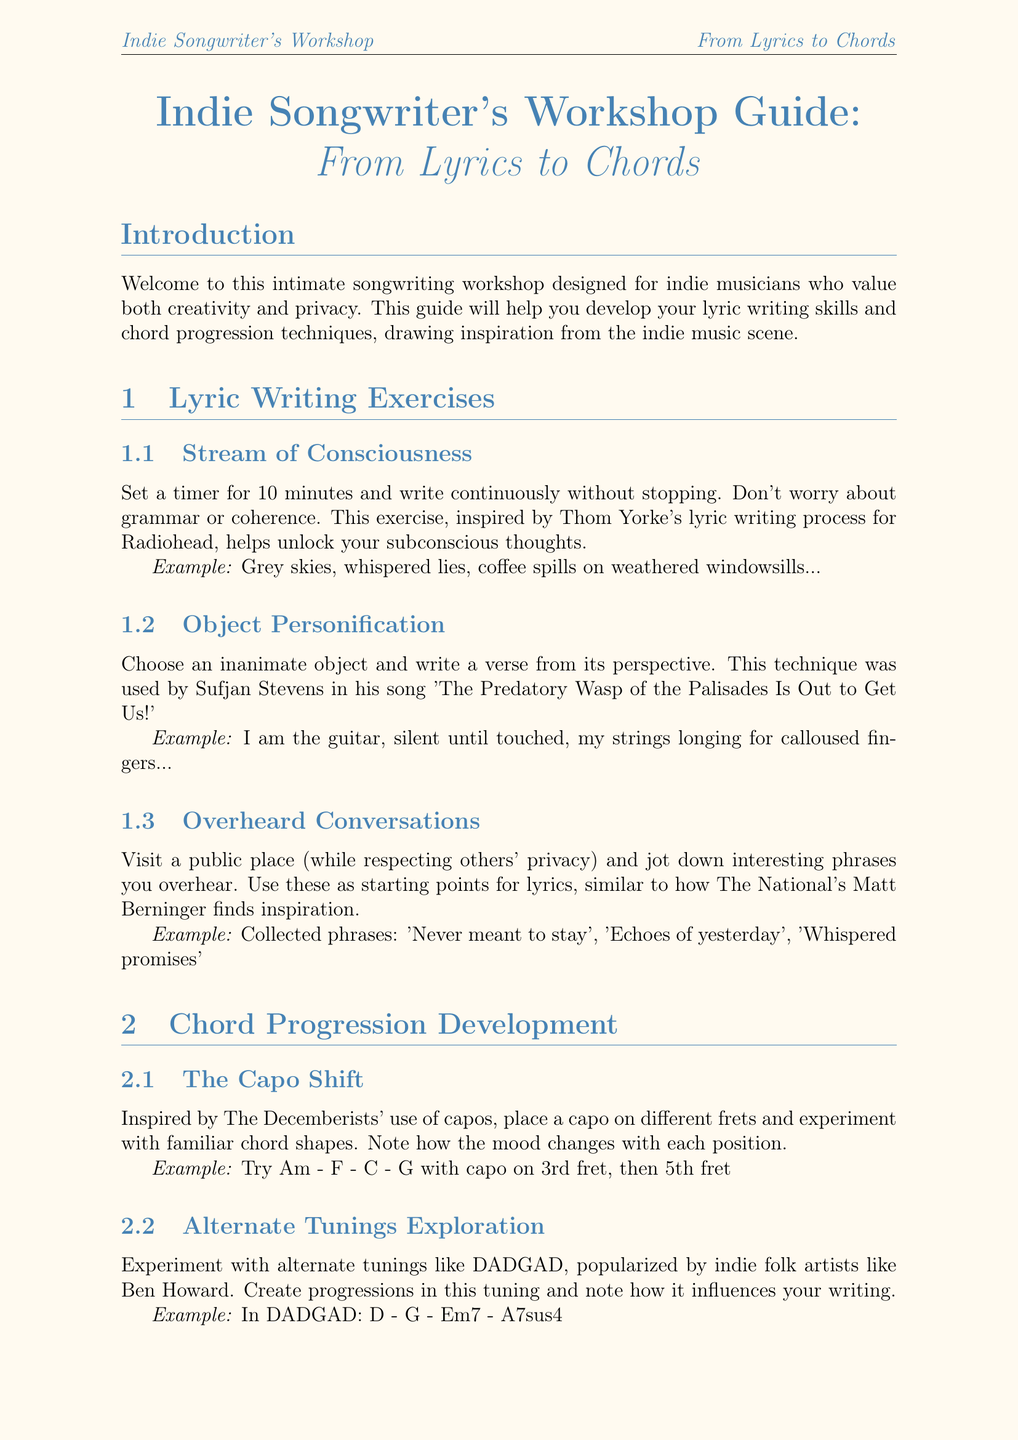What is the title of the guide? The title of the guide is the main heading of the document, which is explicitly stated at the start.
Answer: Indie Songwriter's Workshop Guide: From Lyrics to Chords What is the first exercise listed under Lyric Writing Exercises? The first exercise can be found as a subsection under the Lyric Writing Exercises section.
Answer: Stream of Consciousness Who inspired the Stream of Consciousness exercise? The document mentions an inspirational figure related to each exercise, specifically for this one.
Answer: Thom Yorke What chord progression is suggested in The Capo Shift exercise? The document provides a specific example of a chord progression to try in this exercise.
Answer: Am - F - C - G Which alternate tuning is mentioned in the Chord Progression Development section? This tuning is referenced as being popularized by a specific genre artist, highlighted in the document.
Answer: DADGAD What technique does Bon Iver use for privacy in songwriting? This is described in the Privacy and Personal Expression tips section, providing a specific method for maintaining privacy.
Answer: Metaphors and allegories Which artist's approach is mentioned for creating a songwriting alter ego? The document gives an example of an artist who successfully employed this technique, illustrating a method for personal expression.
Answer: David Bowie How many exercises are listed under the Combining Lyrics and Chords section? The document provides a list of exercises in this specific section, allowing for a straightforward count.
Answer: 2 